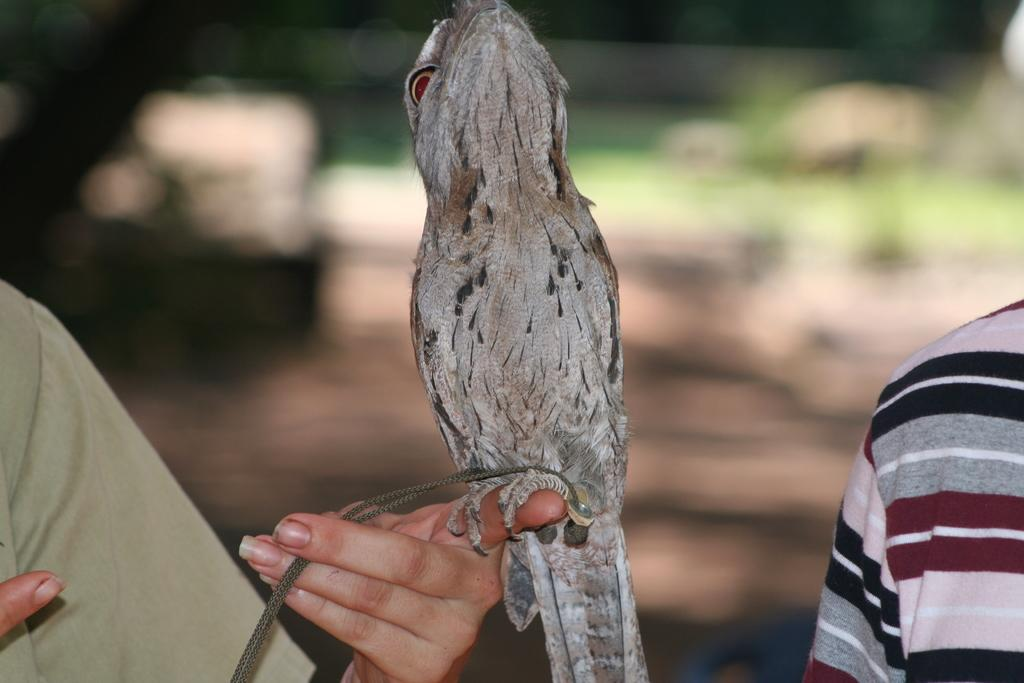How many people are in the image? There are two persons in the image. What is happening with the bird in the image? There is a bird on one person's hand. What object is one person holding? One person is holding a thread. Can you describe the background of the image? The background of the image is blurry. What type of rabbit can be seen hopping near the church in the image? There is no rabbit or church present in the image. What is the quince used for in the person in the image? There is no quince mentioned or visible in the image. 